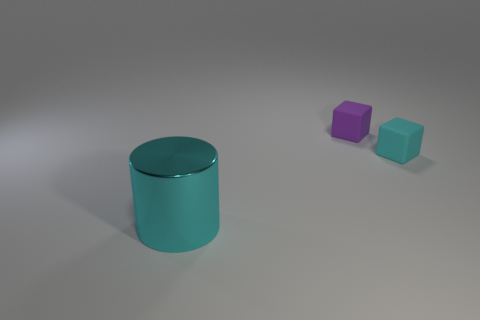Can you provide more details about the large cylindrical object? Certainly! The large cylindrical object in the image has a lustrous turquoise surface and seems quite smooth, suggesting it could be composed of metal or a high-grade plastic with a metallic paint finish. Its size relative to the other objects indicates it may be a significant object in this context, possibly serving as a container or a decorative piece. 